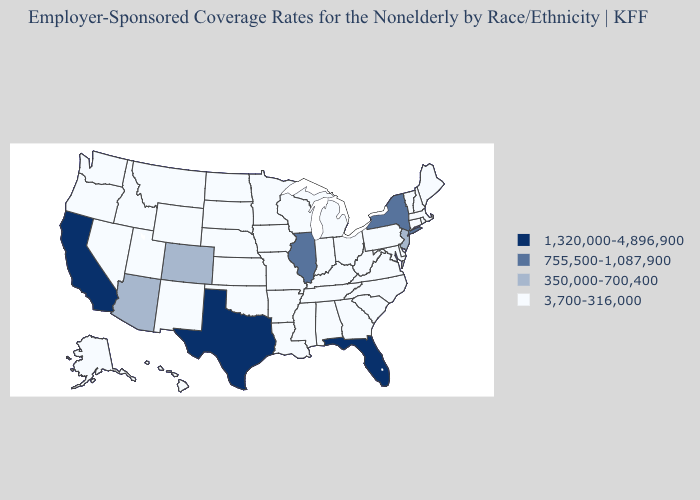Name the states that have a value in the range 1,320,000-4,896,900?
Write a very short answer. California, Florida, Texas. What is the highest value in the South ?
Short answer required. 1,320,000-4,896,900. What is the value of Iowa?
Be succinct. 3,700-316,000. What is the lowest value in states that border West Virginia?
Keep it brief. 3,700-316,000. Name the states that have a value in the range 1,320,000-4,896,900?
Short answer required. California, Florida, Texas. How many symbols are there in the legend?
Short answer required. 4. Is the legend a continuous bar?
Quick response, please. No. Name the states that have a value in the range 1,320,000-4,896,900?
Short answer required. California, Florida, Texas. Name the states that have a value in the range 3,700-316,000?
Short answer required. Alabama, Alaska, Arkansas, Connecticut, Delaware, Georgia, Hawaii, Idaho, Indiana, Iowa, Kansas, Kentucky, Louisiana, Maine, Maryland, Massachusetts, Michigan, Minnesota, Mississippi, Missouri, Montana, Nebraska, Nevada, New Hampshire, New Mexico, North Carolina, North Dakota, Ohio, Oklahoma, Oregon, Pennsylvania, Rhode Island, South Carolina, South Dakota, Tennessee, Utah, Vermont, Virginia, Washington, West Virginia, Wisconsin, Wyoming. What is the lowest value in the USA?
Keep it brief. 3,700-316,000. Does Tennessee have the highest value in the USA?
Quick response, please. No. What is the lowest value in the West?
Be succinct. 3,700-316,000. What is the value of Ohio?
Write a very short answer. 3,700-316,000. Does New Jersey have the highest value in the Northeast?
Keep it brief. No. What is the value of New York?
Keep it brief. 755,500-1,087,900. 